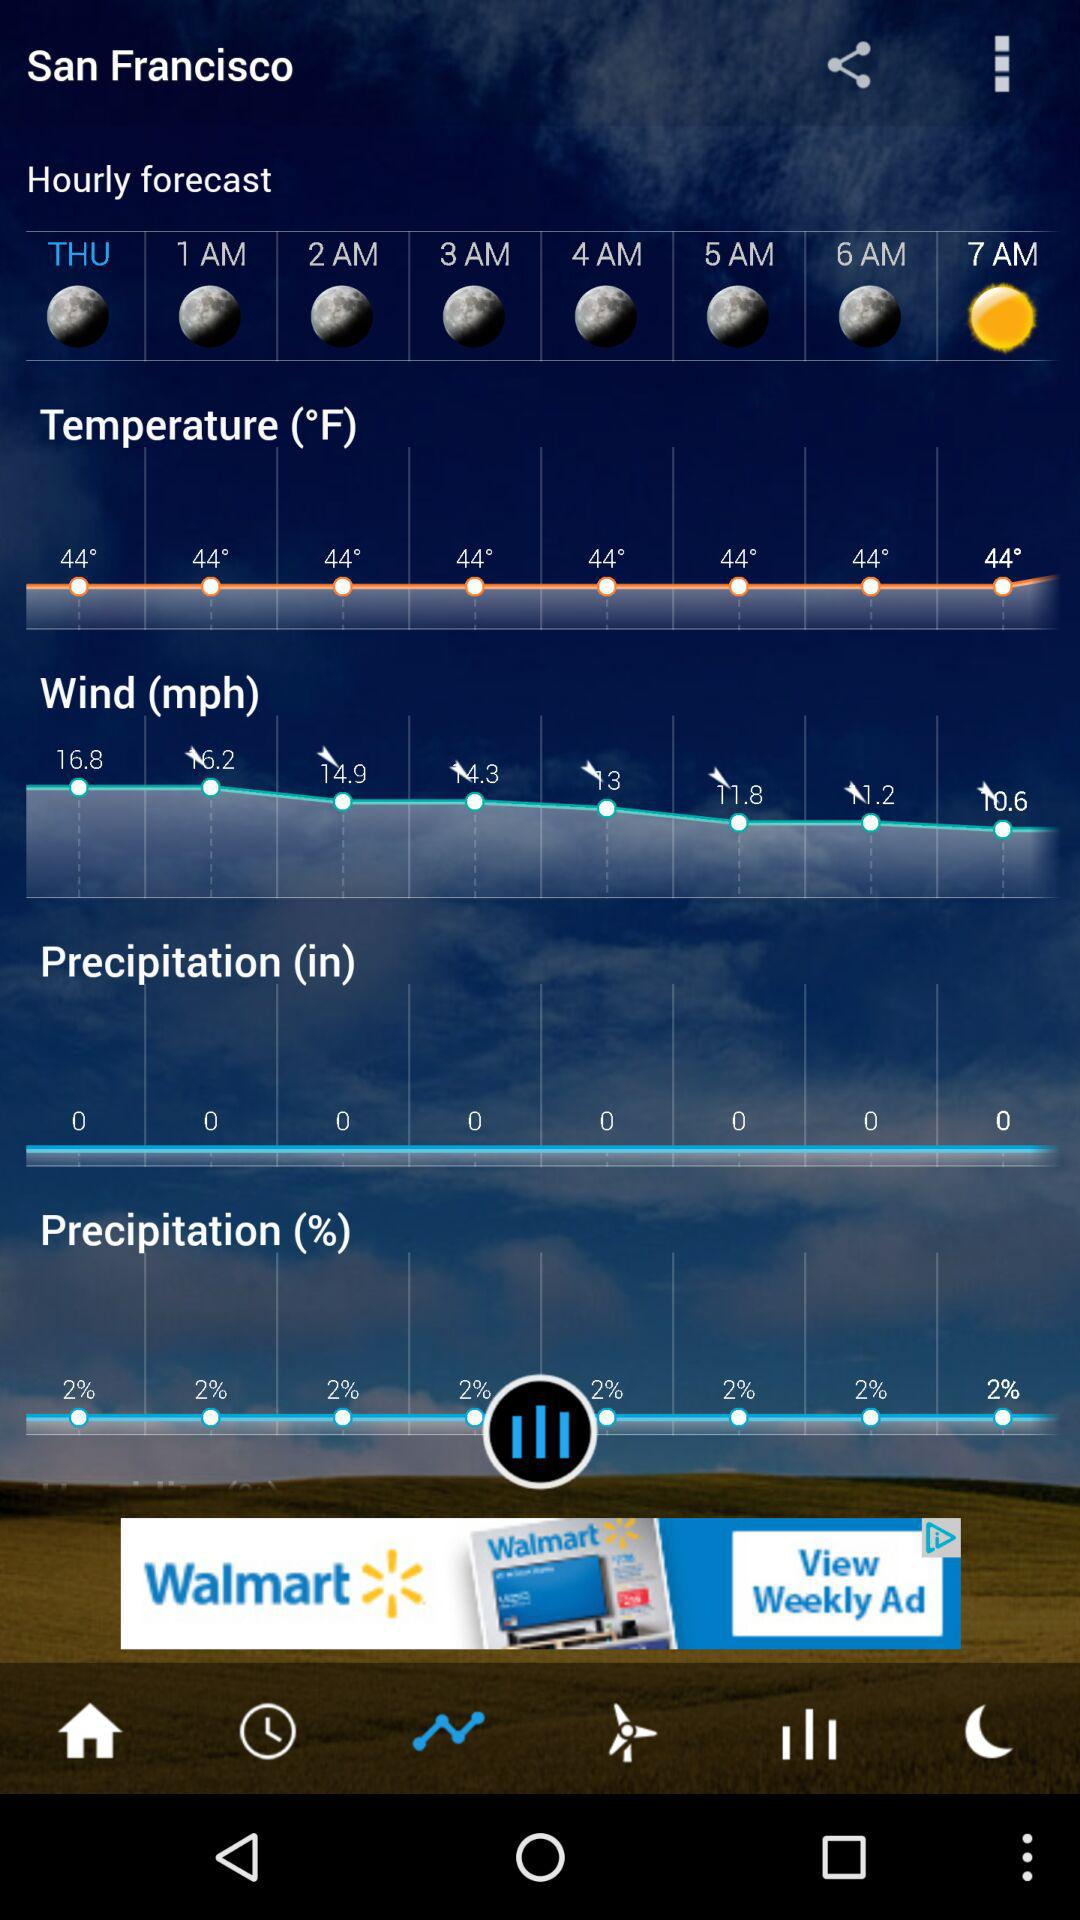How many hours are in the hourly forecast?
Answer the question using a single word or phrase. 7 